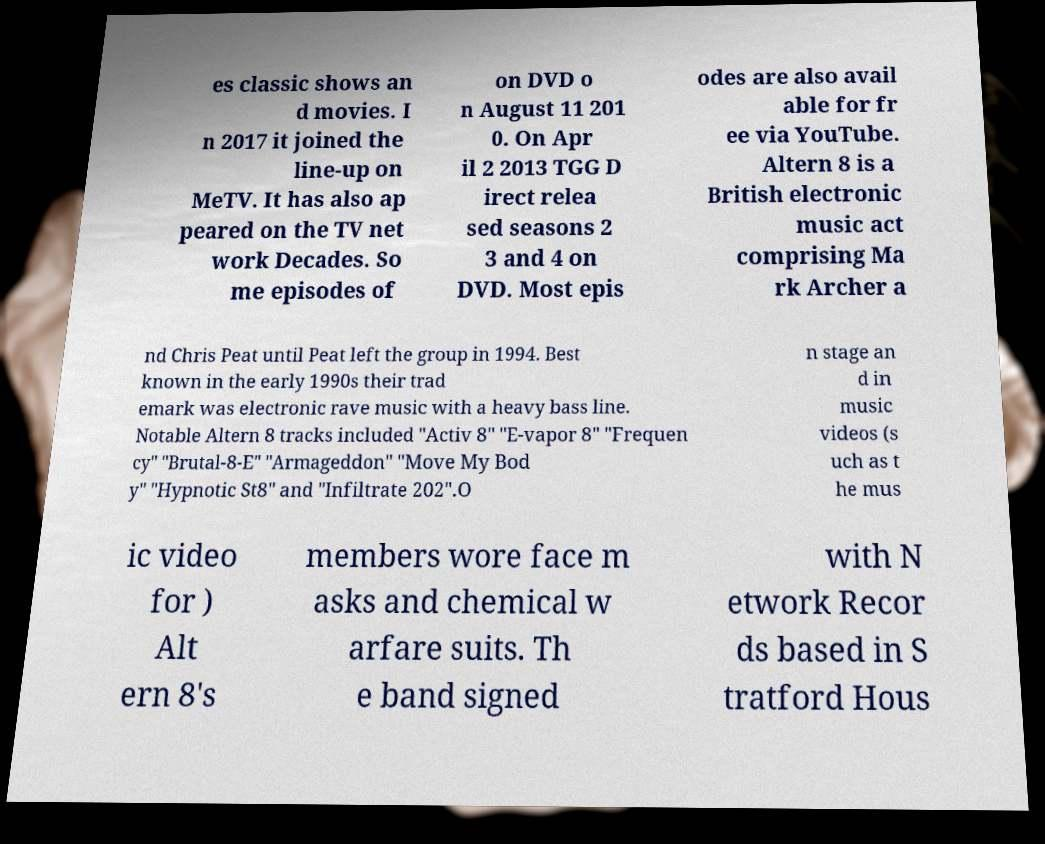Can you read and provide the text displayed in the image?This photo seems to have some interesting text. Can you extract and type it out for me? es classic shows an d movies. I n 2017 it joined the line-up on MeTV. It has also ap peared on the TV net work Decades. So me episodes of on DVD o n August 11 201 0. On Apr il 2 2013 TGG D irect relea sed seasons 2 3 and 4 on DVD. Most epis odes are also avail able for fr ee via YouTube. Altern 8 is a British electronic music act comprising Ma rk Archer a nd Chris Peat until Peat left the group in 1994. Best known in the early 1990s their trad emark was electronic rave music with a heavy bass line. Notable Altern 8 tracks included "Activ 8" "E-vapor 8" "Frequen cy" "Brutal-8-E" "Armageddon" "Move My Bod y" "Hypnotic St8" and "Infiltrate 202".O n stage an d in music videos (s uch as t he mus ic video for ) Alt ern 8's members wore face m asks and chemical w arfare suits. Th e band signed with N etwork Recor ds based in S tratford Hous 